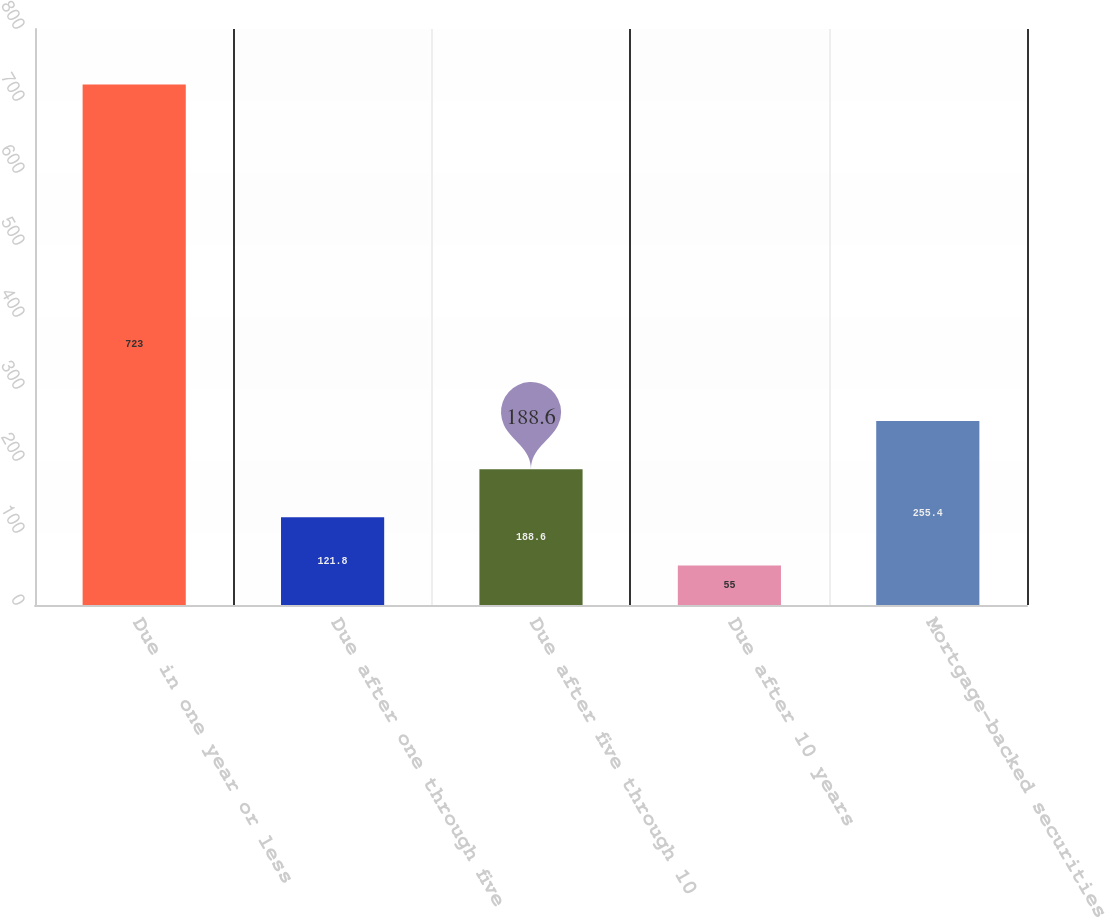<chart> <loc_0><loc_0><loc_500><loc_500><bar_chart><fcel>Due in one year or less<fcel>Due after one through five<fcel>Due after five through 10<fcel>Due after 10 years<fcel>Mortgage-backed securities<nl><fcel>723<fcel>121.8<fcel>188.6<fcel>55<fcel>255.4<nl></chart> 